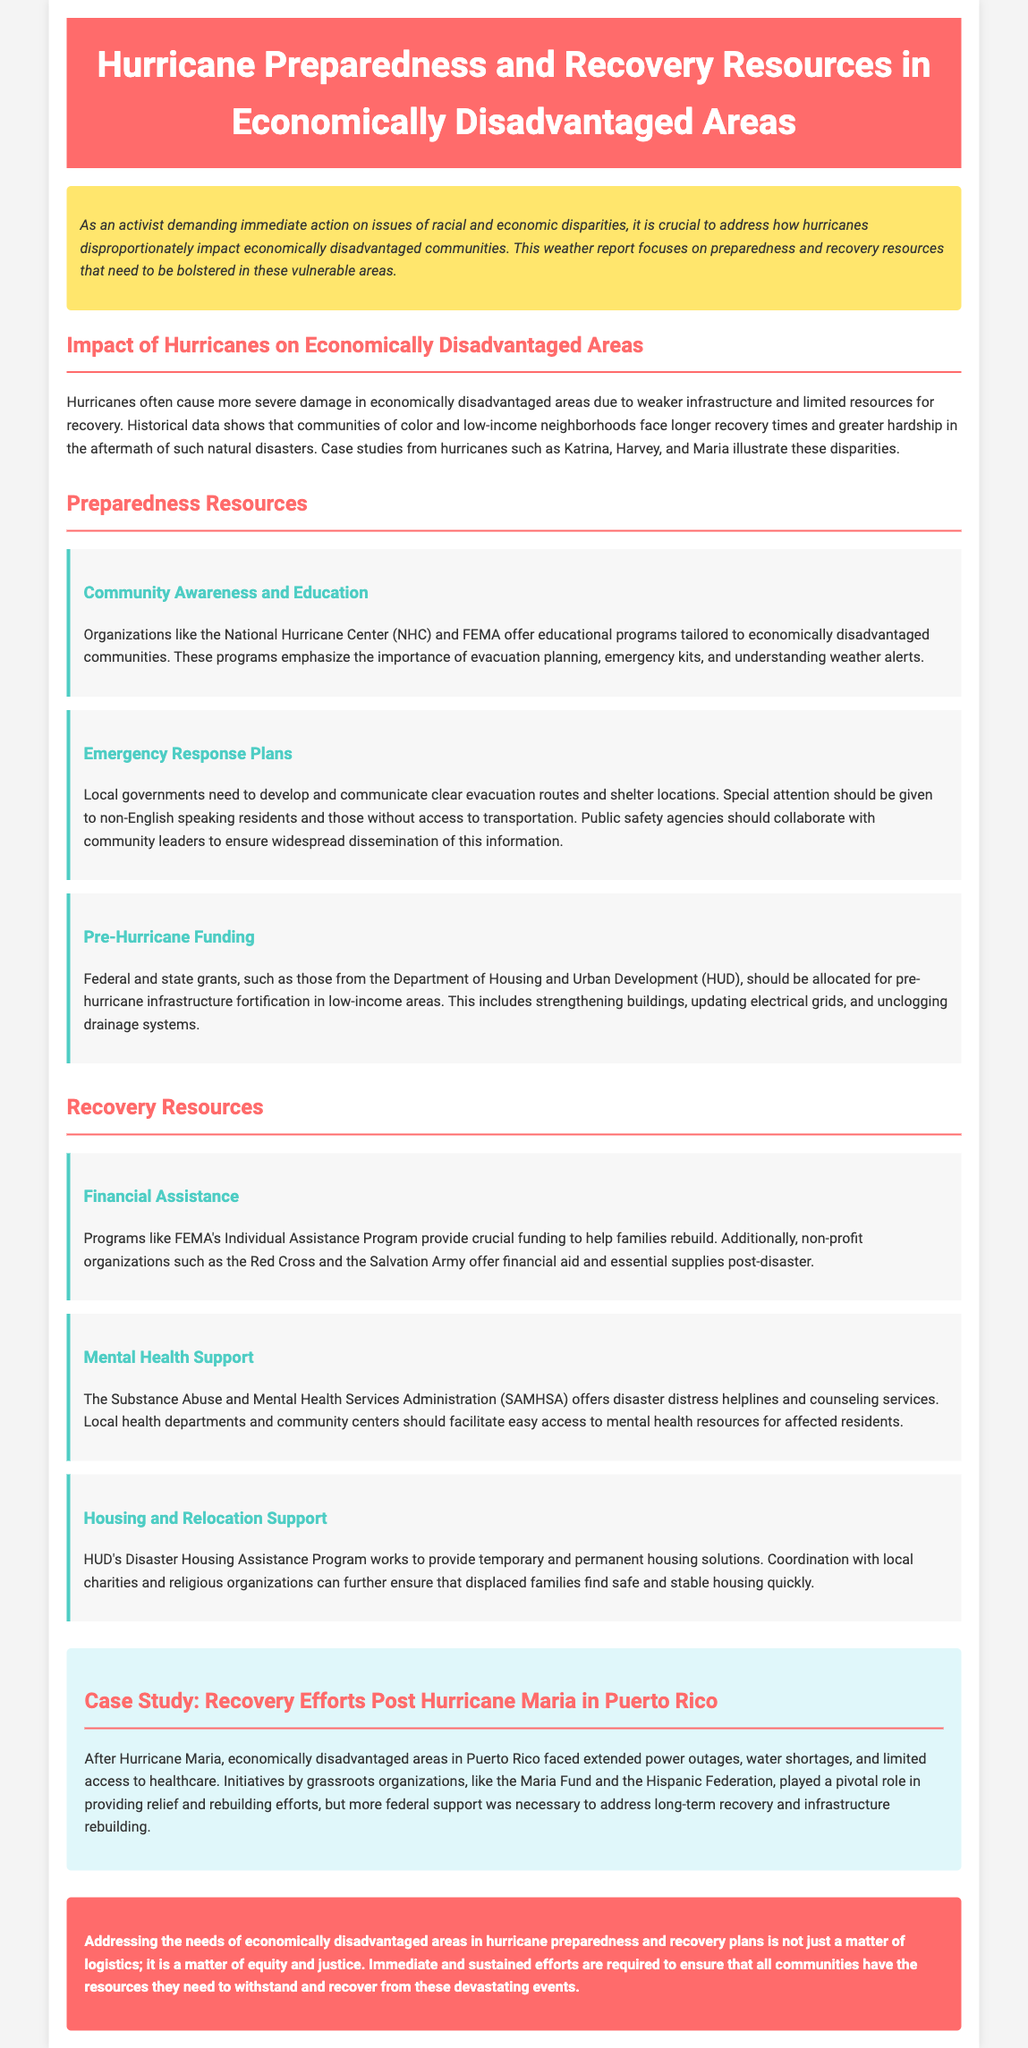What organizations offer educational programs for hurricane preparedness? The document mentions organizations like the National Hurricane Center (NHC) and FEMA that provide educational programs.
Answer: National Hurricane Center, FEMA What is the name of the program that provides housing solutions after disasters? The name of the program mentioned is HUD's Disaster Housing Assistance Program which helps provide housing solutions.
Answer: HUD's Disaster Housing Assistance Program Which hurricane is referenced in the case study about recovery efforts? The case study specifically refers to Hurricane Maria as an example of recovery efforts in economically disadvantaged areas.
Answer: Hurricane Maria What kind of support does SAMHSA provide post-disaster? The Substance Abuse and Mental Health Services Administration (SAMHSA) offers disaster distress helplines and counseling services.
Answer: Mental Health Support What type of funding is emphasized for pre-hurricane infrastructure fortification? The document emphasizes federal and state grants, particularly those from the Department of Housing and Urban Development (HUD).
Answer: Federal and state grants How do hurricanes affect economically disadvantaged areas according to historical data? Historically, communities of color and low-income neighborhoods face longer recovery times and greater hardship after hurricanes.
Answer: Longer recovery times and greater hardship 